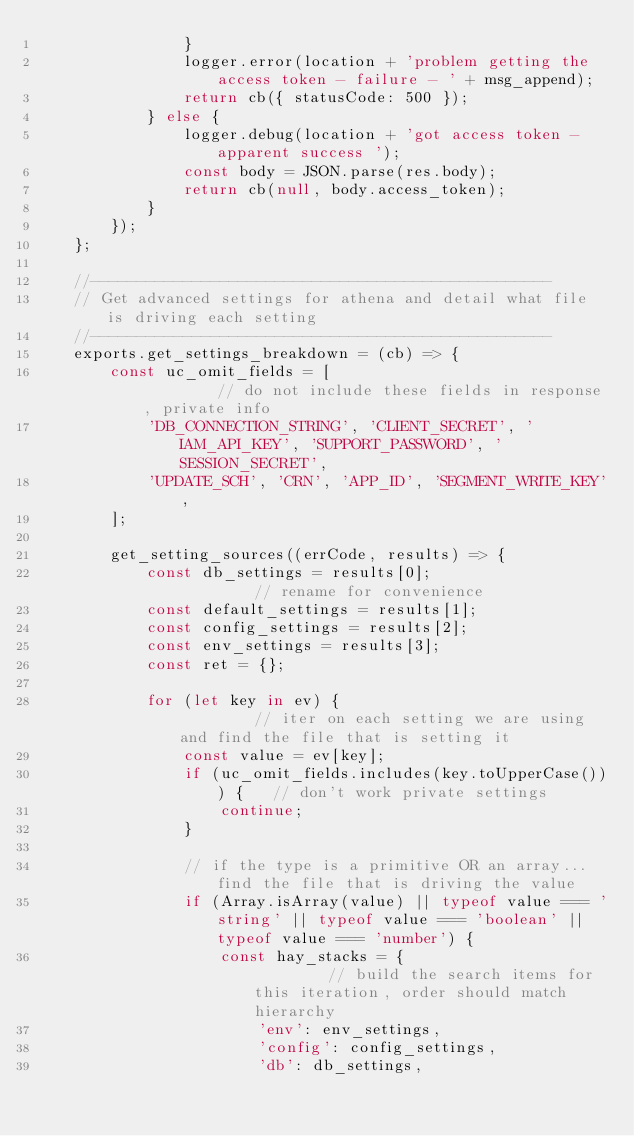Convert code to text. <code><loc_0><loc_0><loc_500><loc_500><_JavaScript_>				}
				logger.error(location + 'problem getting the access token - failure - ' + msg_append);
				return cb({ statusCode: 500 });
			} else {
				logger.debug(location + 'got access token - apparent success ');
				const body = JSON.parse(res.body);
				return cb(null, body.access_token);
			}
		});
	};

	//--------------------------------------------------
	// Get advanced settings for athena and detail what file is driving each setting
	//--------------------------------------------------
	exports.get_settings_breakdown = (cb) => {
		const uc_omit_fields = [									// do not include these fields in response, private info
			'DB_CONNECTION_STRING', 'CLIENT_SECRET', 'IAM_API_KEY', 'SUPPORT_PASSWORD', 'SESSION_SECRET',
			'UPDATE_SCH', 'CRN', 'APP_ID', 'SEGMENT_WRITE_KEY',
		];

		get_setting_sources((errCode, results) => {
			const db_settings = results[0];							// rename for convenience
			const default_settings = results[1];
			const config_settings = results[2];
			const env_settings = results[3];
			const ret = {};

			for (let key in ev) {									// iter on each setting we are using and find the file that is setting it
				const value = ev[key];
				if (uc_omit_fields.includes(key.toUpperCase())) {	// don't work private settings
					continue;
				}

				// if the type is a primitive OR an array... find the file that is driving the value
				if (Array.isArray(value) || typeof value === 'string' || typeof value === 'boolean' || typeof value === 'number') {
					const hay_stacks = {							// build the search items for this iteration, order should match hierarchy
						'env': env_settings,
						'config': config_settings,
						'db': db_settings,</code> 